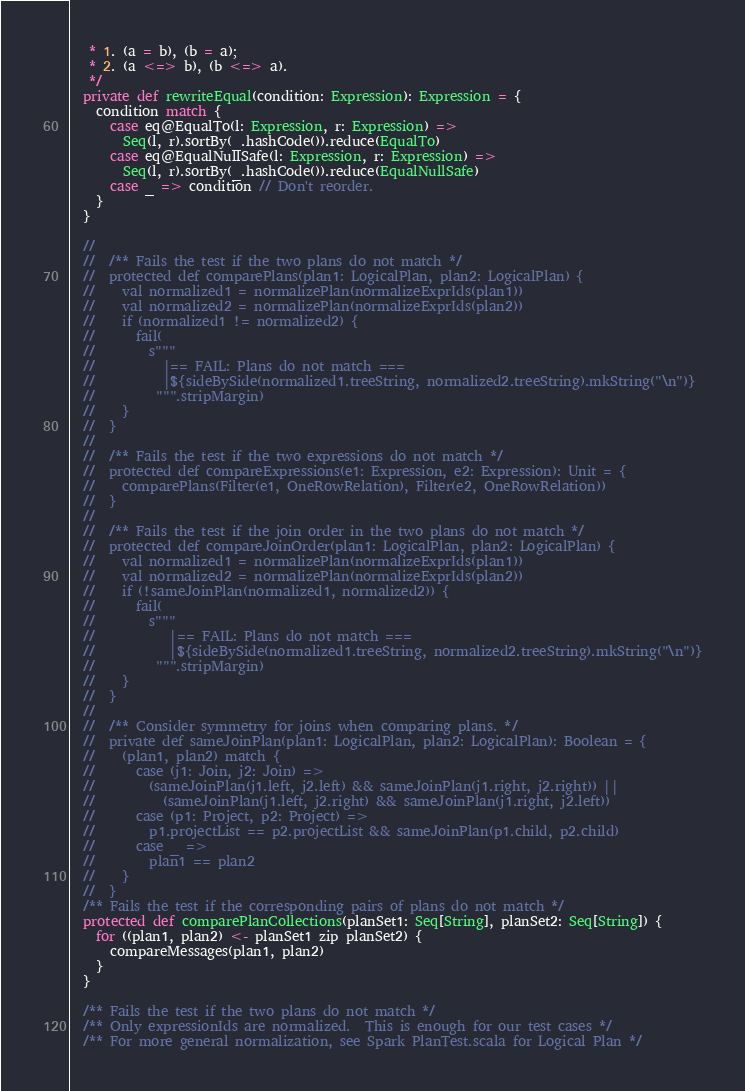Convert code to text. <code><loc_0><loc_0><loc_500><loc_500><_Scala_>   * 1. (a = b), (b = a);
   * 2. (a <=> b), (b <=> a).
   */
  private def rewriteEqual(condition: Expression): Expression = {
    condition match {
      case eq@EqualTo(l: Expression, r: Expression) =>
        Seq(l, r).sortBy(_.hashCode()).reduce(EqualTo)
      case eq@EqualNullSafe(l: Expression, r: Expression) =>
        Seq(l, r).sortBy(_.hashCode()).reduce(EqualNullSafe)
      case _ => condition // Don't reorder.
    }
  }

  //
  //  /** Fails the test if the two plans do not match */
  //  protected def comparePlans(plan1: LogicalPlan, plan2: LogicalPlan) {
  //    val normalized1 = normalizePlan(normalizeExprIds(plan1))
  //    val normalized2 = normalizePlan(normalizeExprIds(plan2))
  //    if (normalized1 != normalized2) {
  //      fail(
  //        s"""
  //          |== FAIL: Plans do not match ===
  //          |${sideBySide(normalized1.treeString, normalized2.treeString).mkString("\n")}
  //         """.stripMargin)
  //    }
  //  }
  //
  //  /** Fails the test if the two expressions do not match */
  //  protected def compareExpressions(e1: Expression, e2: Expression): Unit = {
  //    comparePlans(Filter(e1, OneRowRelation), Filter(e2, OneRowRelation))
  //  }
  //
  //  /** Fails the test if the join order in the two plans do not match */
  //  protected def compareJoinOrder(plan1: LogicalPlan, plan2: LogicalPlan) {
  //    val normalized1 = normalizePlan(normalizeExprIds(plan1))
  //    val normalized2 = normalizePlan(normalizeExprIds(plan2))
  //    if (!sameJoinPlan(normalized1, normalized2)) {
  //      fail(
  //        s"""
  //           |== FAIL: Plans do not match ===
  //           |${sideBySide(normalized1.treeString, normalized2.treeString).mkString("\n")}
  //         """.stripMargin)
  //    }
  //  }
  //
  //  /** Consider symmetry for joins when comparing plans. */
  //  private def sameJoinPlan(plan1: LogicalPlan, plan2: LogicalPlan): Boolean = {
  //    (plan1, plan2) match {
  //      case (j1: Join, j2: Join) =>
  //        (sameJoinPlan(j1.left, j2.left) && sameJoinPlan(j1.right, j2.right)) ||
  //          (sameJoinPlan(j1.left, j2.right) && sameJoinPlan(j1.right, j2.left))
  //      case (p1: Project, p2: Project) =>
  //        p1.projectList == p2.projectList && sameJoinPlan(p1.child, p2.child)
  //      case _ =>
  //        plan1 == plan2
  //    }
  //  }
  /** Fails the test if the corresponding pairs of plans do not match */
  protected def comparePlanCollections(planSet1: Seq[String], planSet2: Seq[String]) {
    for ((plan1, plan2) <- planSet1 zip planSet2) {
      compareMessages(plan1, plan2)
    }
  }

  /** Fails the test if the two plans do not match */
  /** Only expressionIds are normalized.  This is enough for our test cases */
  /** For more general normalization, see Spark PlanTest.scala for Logical Plan */</code> 